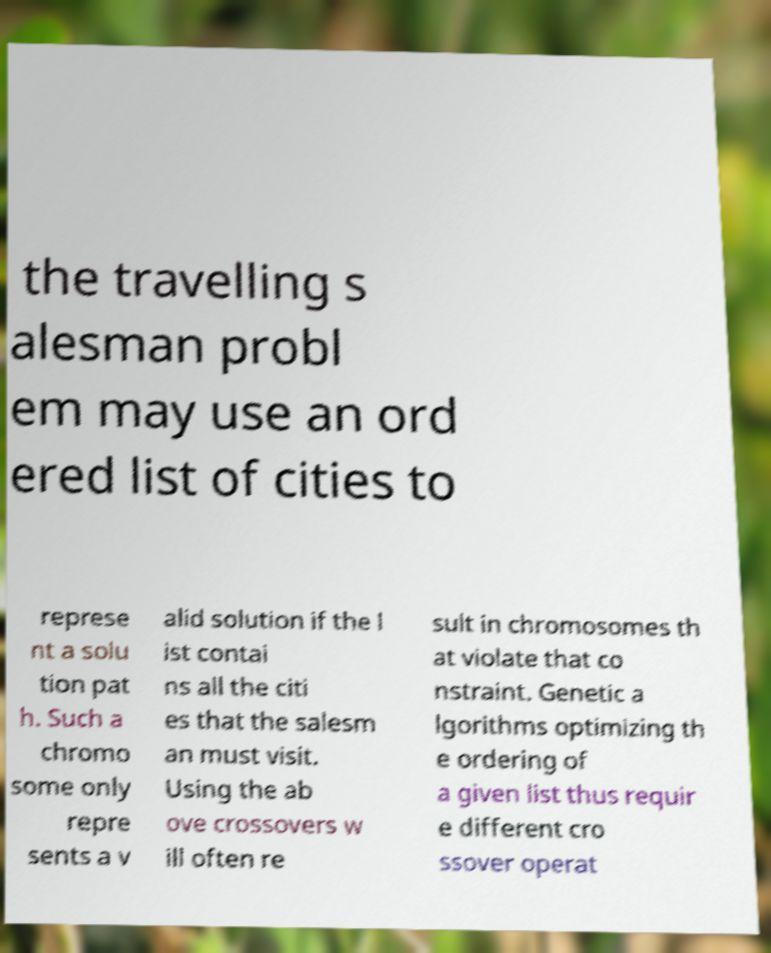Could you extract and type out the text from this image? the travelling s alesman probl em may use an ord ered list of cities to represe nt a solu tion pat h. Such a chromo some only repre sents a v alid solution if the l ist contai ns all the citi es that the salesm an must visit. Using the ab ove crossovers w ill often re sult in chromosomes th at violate that co nstraint. Genetic a lgorithms optimizing th e ordering of a given list thus requir e different cro ssover operat 